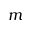Convert formula to latex. <formula><loc_0><loc_0><loc_500><loc_500>m</formula> 